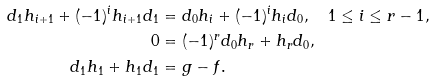<formula> <loc_0><loc_0><loc_500><loc_500>d _ { 1 } h _ { i + 1 } + ( - 1 ) ^ { i } h _ { i + 1 } d _ { 1 } & = d _ { 0 } h _ { i } + ( - 1 ) ^ { i } h _ { i } d _ { 0 } , \quad 1 \leq i \leq r - 1 , \\ 0 & = ( - 1 ) ^ { r } d _ { 0 } h _ { r } + h _ { r } d _ { 0 } , \\ d _ { 1 } h _ { 1 } + h _ { 1 } d _ { 1 } & = g - f .</formula> 